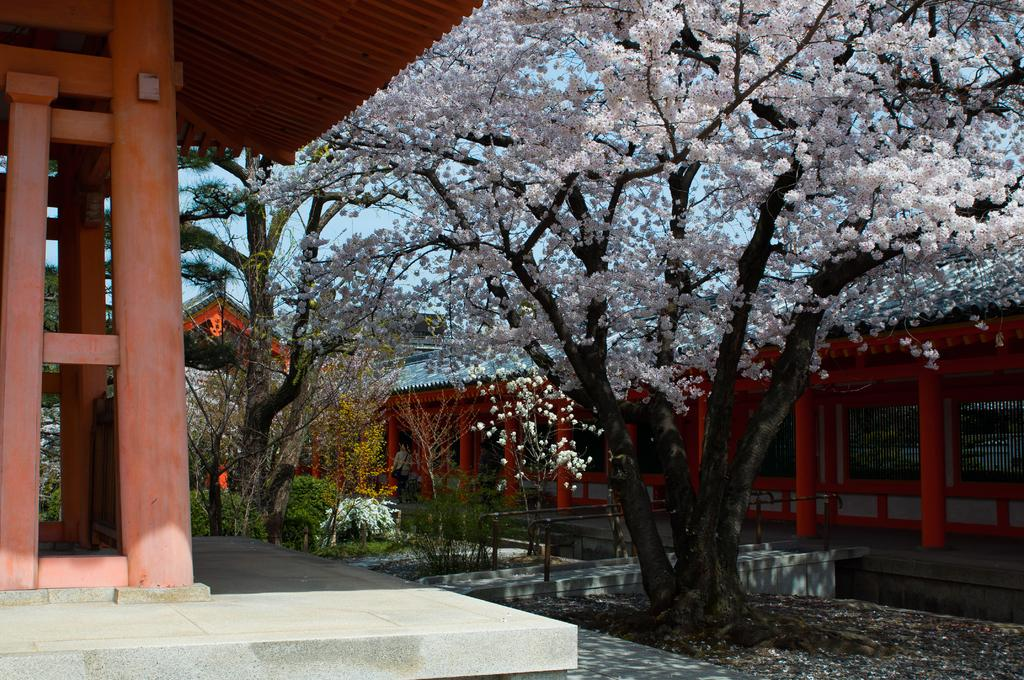What structures are located on the sides of the image? There are houses on either side of the image. What type of vegetation is in the center of the image? There are trees and plants in the center of the image. What is visible at the top of the image? The sky is visible at the top of the image. Where is the table located in the image? There is no table present in the image. What shape is the mouth of the tree in the image? There is no mouth present in the image, as trees do not have mouths. 